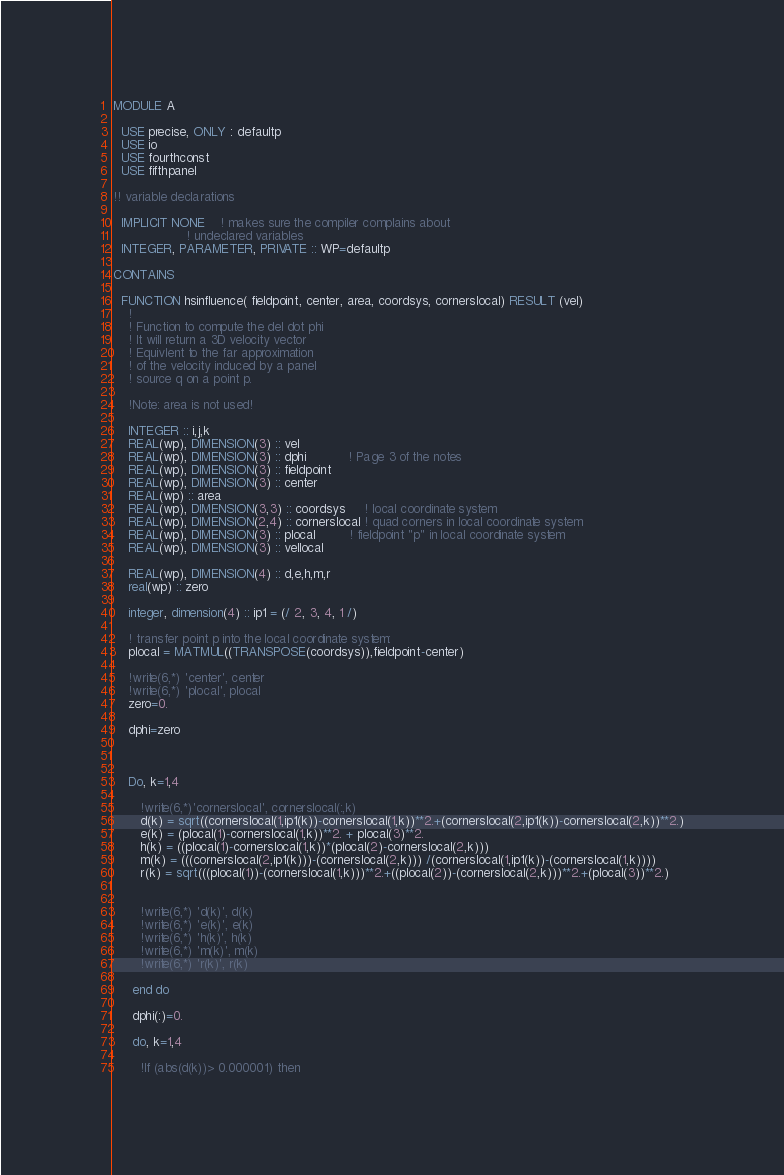<code> <loc_0><loc_0><loc_500><loc_500><_FORTRAN_>MODULE A

  USE precise, ONLY : defaultp
  USE io
  USE fourthconst
  USE fifthpanel

!! variable declarations

  IMPLICIT NONE    ! makes sure the compiler complains about 
                   ! undeclared variables
  INTEGER, PARAMETER, PRIVATE :: WP=defaultp

CONTAINS

  FUNCTION hsinfluence( fieldpoint, center, area, coordsys, cornerslocal) RESULT (vel)
    !
    ! Function to compute the del dot phi
    ! It will return a 3D velocity vector
    ! Equivlent to the far approximation
    ! of the velocity induced by a panel
    ! source q on a point p.

    !Note: area is not used!

    INTEGER :: i,j,k
    REAL(wp), DIMENSION(3) :: vel
    REAL(wp), DIMENSION(3) :: dphi           ! Page 3 of the notes
    REAL(wp), DIMENSION(3) :: fieldpoint
    REAL(wp), DIMENSION(3) :: center
    REAL(wp) :: area
    REAL(wp), DIMENSION(3,3) :: coordsys     ! local coordinate system
    REAL(wp), DIMENSION(2,4) :: cornerslocal ! quad corners in local coordinate system
    REAL(wp), DIMENSION(3) :: plocal         ! fieldpoint "p" in local coordinate system
    REAL(wp), DIMENSION(3) :: vellocal

    REAL(wp), DIMENSION(4) :: d,e,h,m,r
    real(wp) :: zero

    integer, dimension(4) :: ip1 = (/ 2, 3, 4, 1 /)

    ! transfer point p into the local coordinate system:
    plocal = MATMUL((TRANSPOSE(coordsys)),fieldpoint-center)
    
    !write(6,*) 'center', center
    !write(6,*) 'plocal', plocal 
    zero=0.

    dphi=zero



    Do, k=1,4     
      
       !write(6,*)'cornerslocal', cornerslocal(:,k)      
       d(k) = sqrt((cornerslocal(1,ip1(k))-cornerslocal(1,k))**2.+(cornerslocal(2,ip1(k))-cornerslocal(2,k))**2.)
       e(k) = (plocal(1)-cornerslocal(1,k))**2. + plocal(3)**2.
       h(k) = ((plocal(1)-cornerslocal(1,k))*(plocal(2)-cornerslocal(2,k)))
       m(k) = (((cornerslocal(2,ip1(k)))-(cornerslocal(2,k))) /(cornerslocal(1,ip1(k))-(cornerslocal(1,k))))
       r(k) = sqrt(((plocal(1))-(cornerslocal(1,k)))**2.+((plocal(2))-(cornerslocal(2,k)))**2.+(plocal(3))**2.)


       !write(6,*) 'd(k)', d(k)
       !write(6,*) 'e(k)', e(k)
       !write(6,*) 'h(k)', h(k)
       !write(6,*) 'm(k)', m(k)
       !write(6,*) 'r(k)', r(k)

     end do

     dphi(:)=0.

     do, k=1,4

       !If (abs(d(k))> 0.000001) then   </code> 